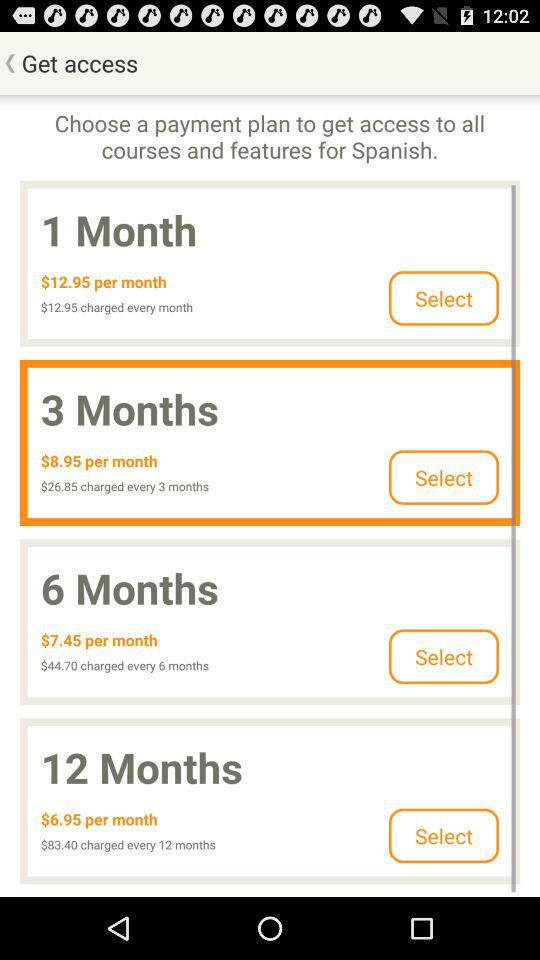What is the amount of the payment plan for 1 month? The amount of the payment plan for 1 month is $12.95. 